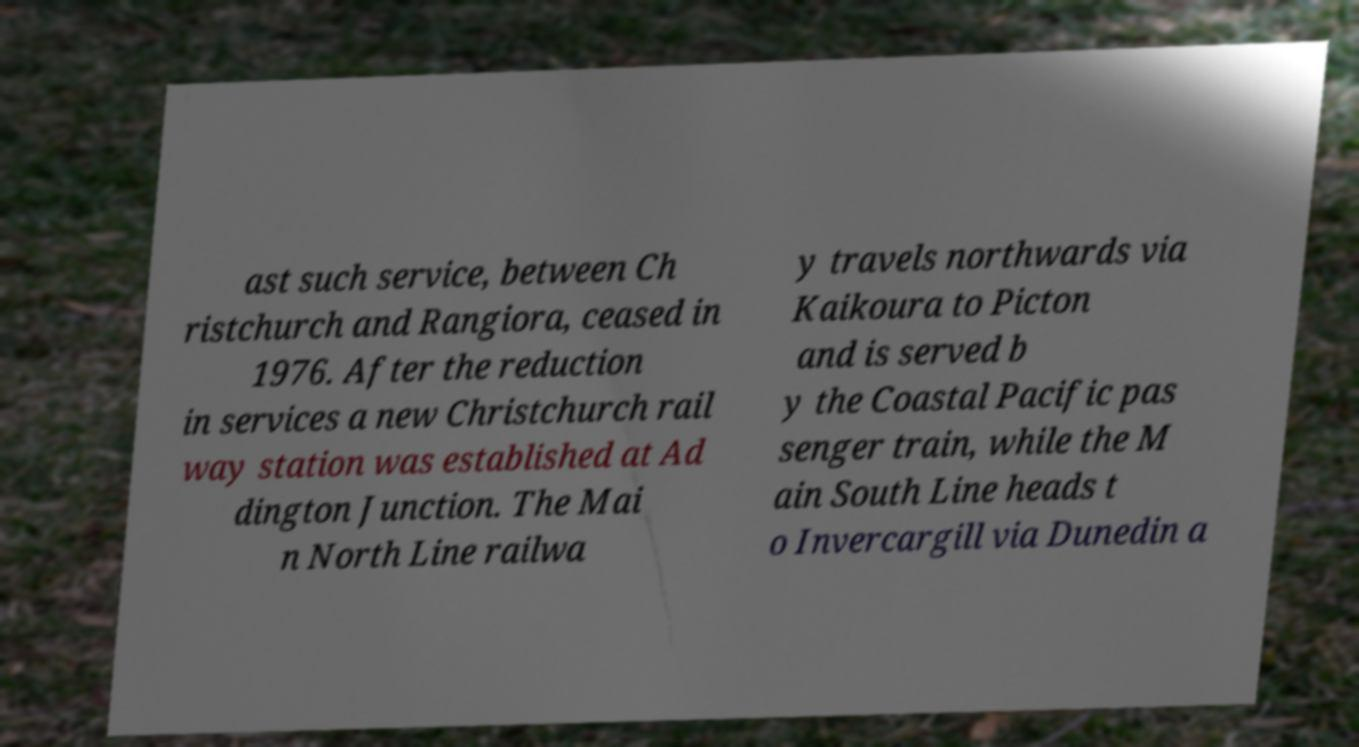What messages or text are displayed in this image? I need them in a readable, typed format. ast such service, between Ch ristchurch and Rangiora, ceased in 1976. After the reduction in services a new Christchurch rail way station was established at Ad dington Junction. The Mai n North Line railwa y travels northwards via Kaikoura to Picton and is served b y the Coastal Pacific pas senger train, while the M ain South Line heads t o Invercargill via Dunedin a 